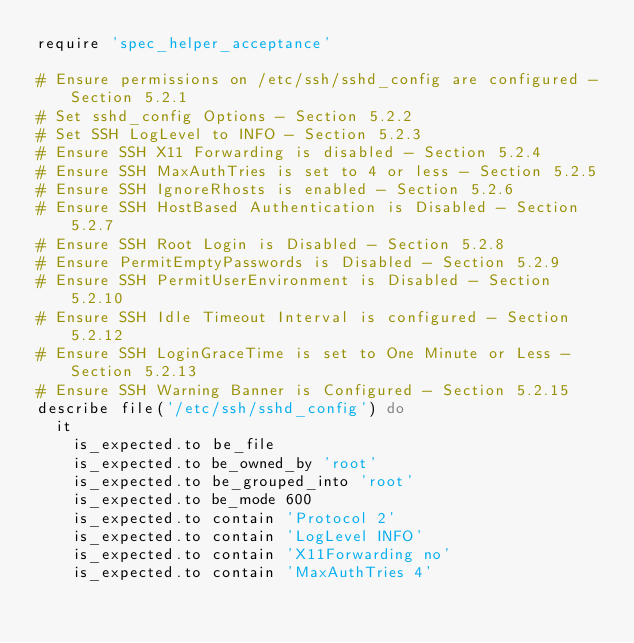<code> <loc_0><loc_0><loc_500><loc_500><_Ruby_>require 'spec_helper_acceptance'

# Ensure permissions on /etc/ssh/sshd_config are configured - Section 5.2.1
# Set sshd_config Options - Section 5.2.2
# Set SSH LogLevel to INFO - Section 5.2.3
# Ensure SSH X11 Forwarding is disabled - Section 5.2.4
# Ensure SSH MaxAuthTries is set to 4 or less - Section 5.2.5
# Ensure SSH IgnoreRhosts is enabled - Section 5.2.6
# Ensure SSH HostBased Authentication is Disabled - Section 5.2.7
# Ensure SSH Root Login is Disabled - Section 5.2.8
# Ensure PermitEmptyPasswords is Disabled - Section 5.2.9
# Ensure SSH PermitUserEnvironment is Disabled - Section 5.2.10
# Ensure SSH Idle Timeout Interval is configured - Section 5.2.12
# Ensure SSH LoginGraceTime is set to One Minute or Less - Section 5.2.13
# Ensure SSH Warning Banner is Configured - Section 5.2.15
describe file('/etc/ssh/sshd_config') do
  it 
    is_expected.to be_file
    is_expected.to be_owned_by 'root'
    is_expected.to be_grouped_into 'root'
    is_expected.to be_mode 600
    is_expected.to contain 'Protocol 2'
    is_expected.to contain 'LogLevel INFO'
    is_expected.to contain 'X11Forwarding no'
    is_expected.to contain 'MaxAuthTries 4'</code> 